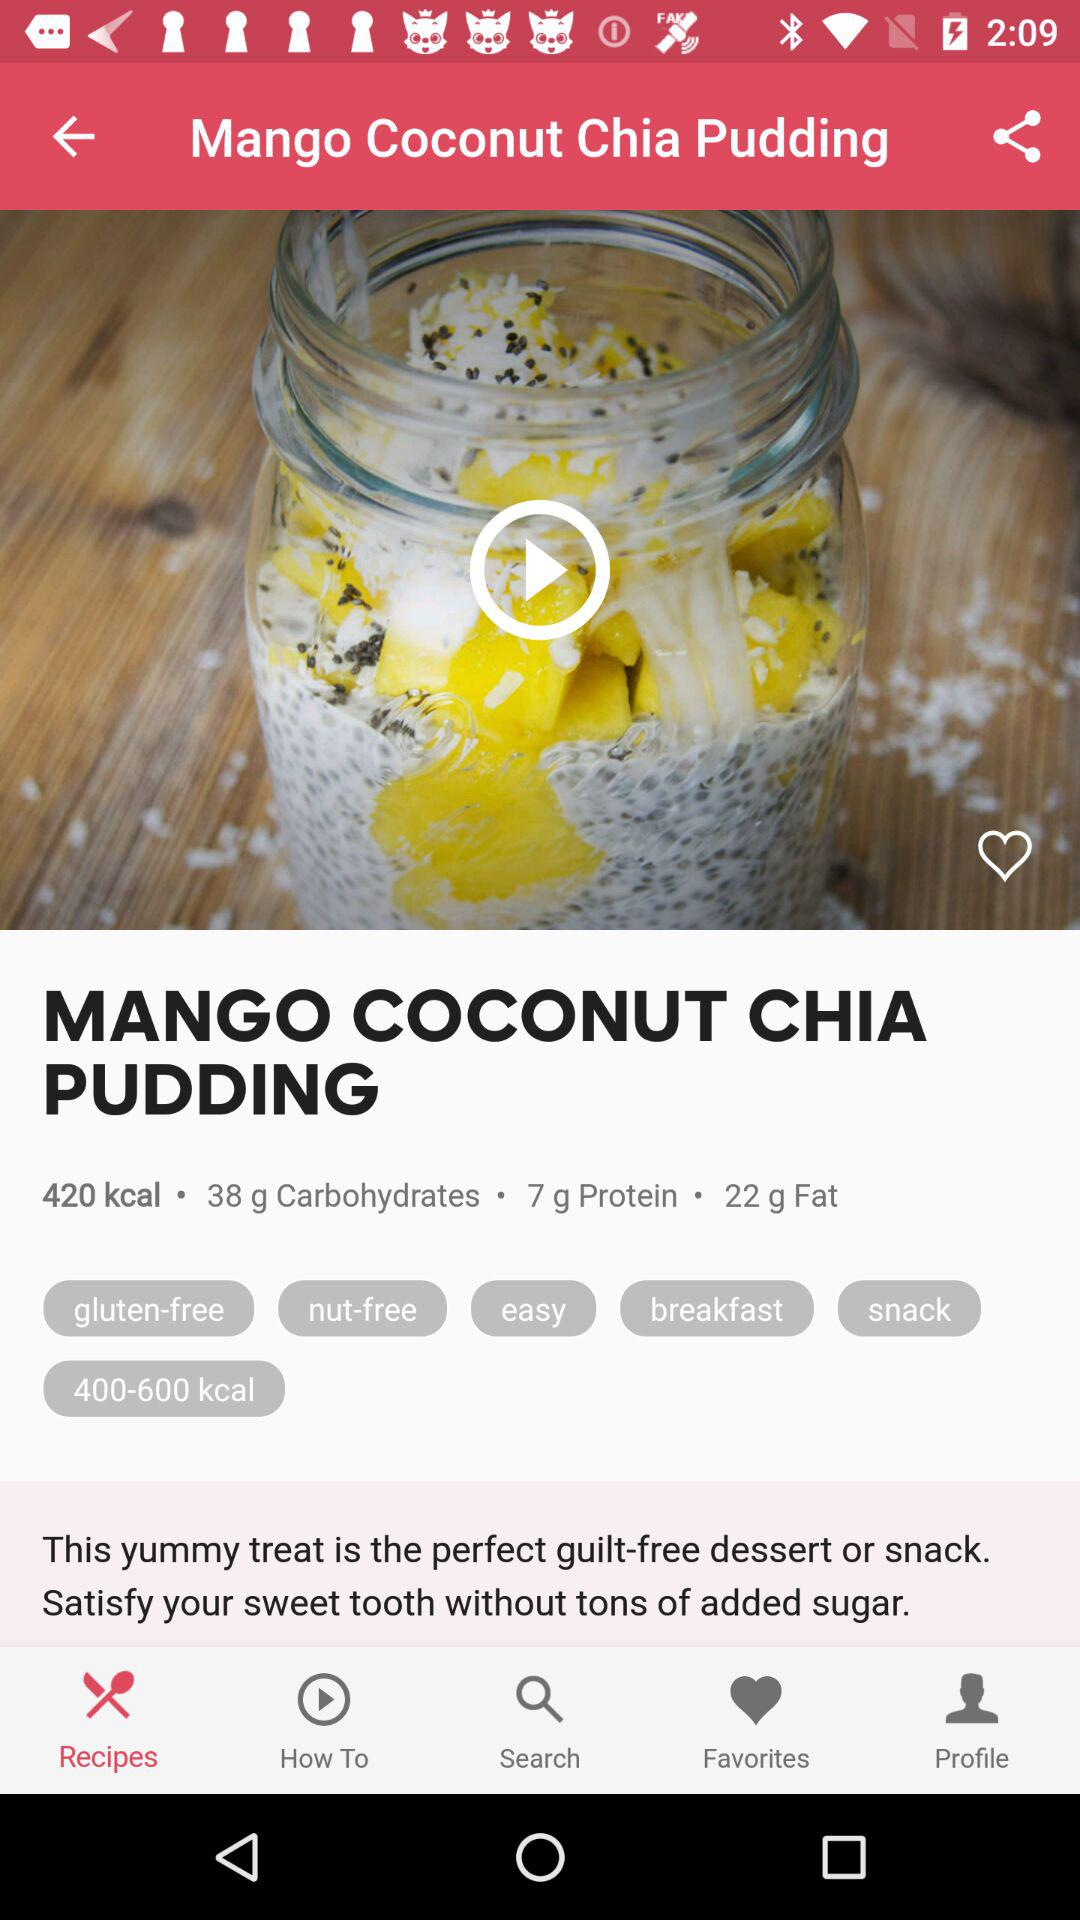How many carbs are in this recipe?
Answer the question using a single word or phrase. 38 g 